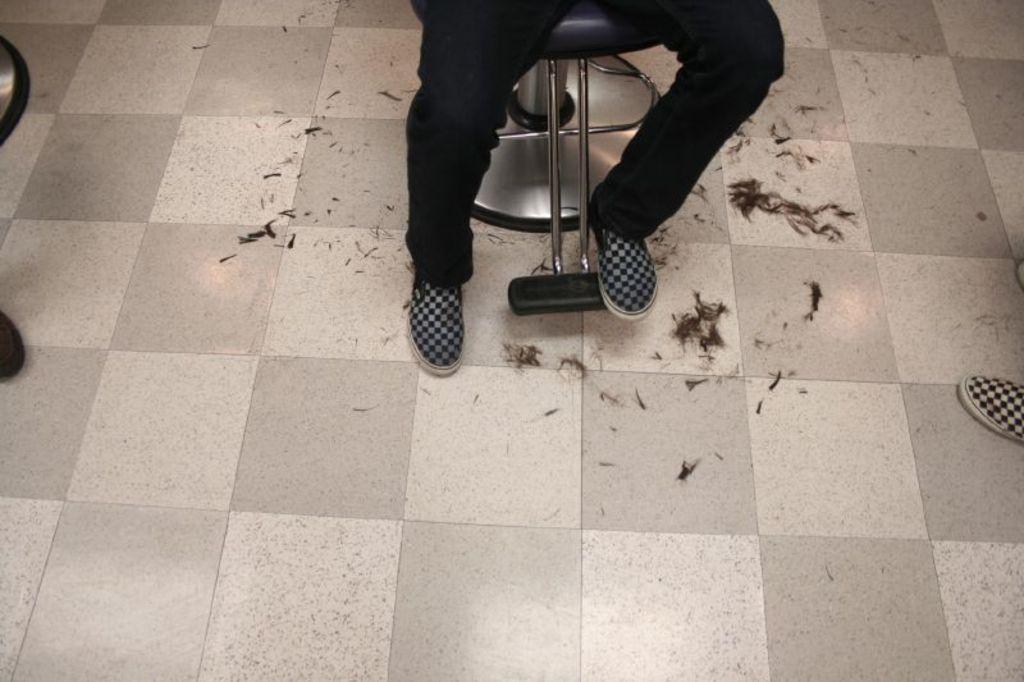Please provide a concise description of this image. In this image we can see two legs with shoes on the chair, two chairs, one shoe and some hair on the floor. 